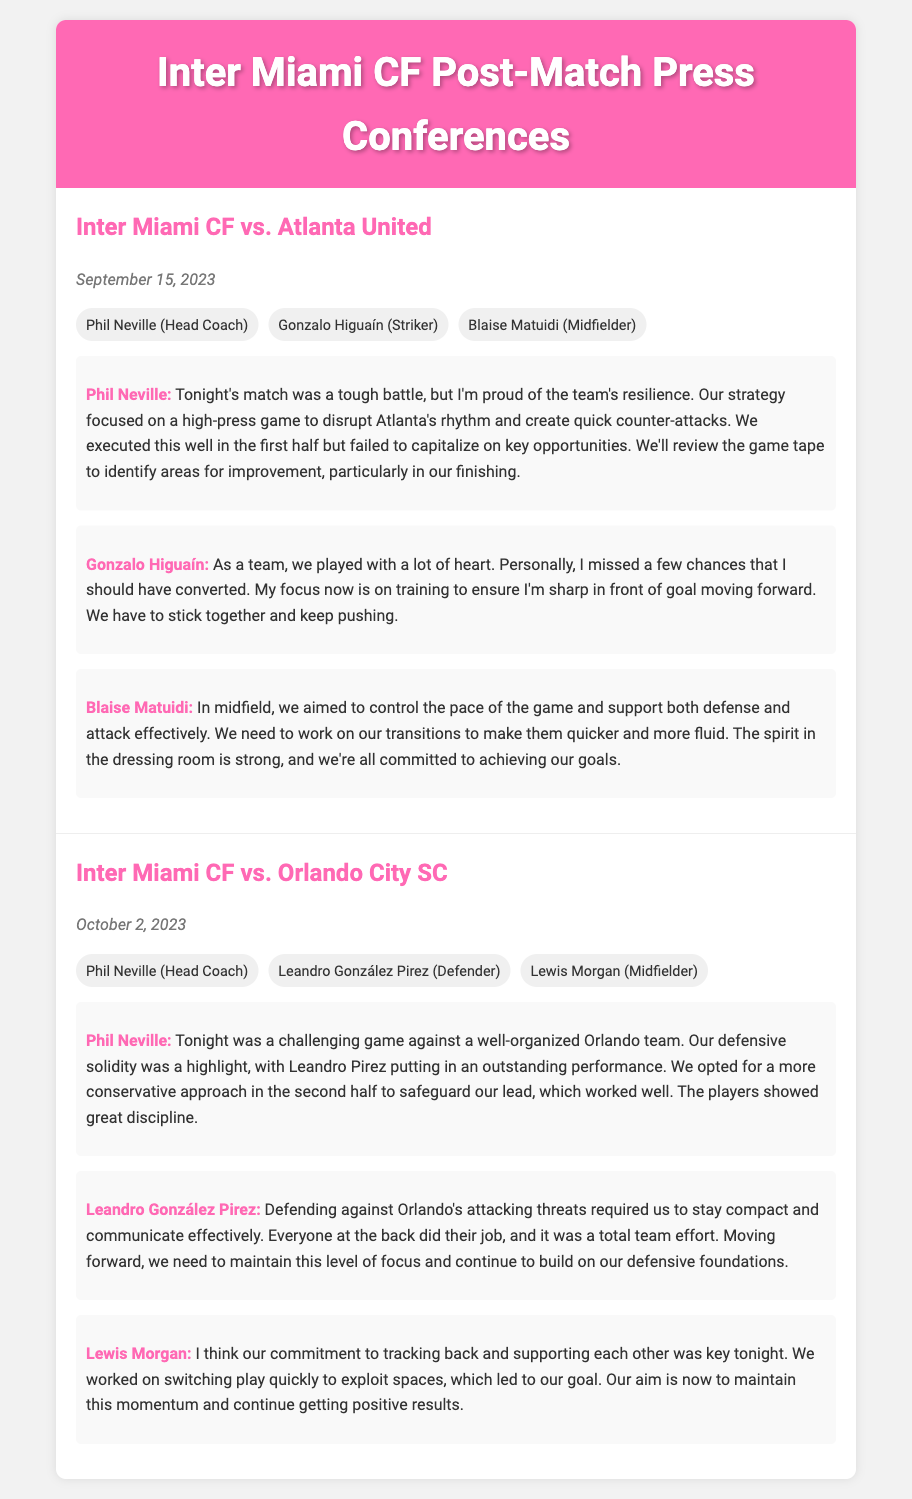What date was the match against Atlanta United? The match against Atlanta United took place on September 15, 2023.
Answer: September 15, 2023 Who made an outstanding performance as noted by Phil Neville against Orlando? Phil Neville highlighted Leandro González Pirez's performance as outstanding in the game against Orlando.
Answer: Leandro González Pirez What was Gonzalo Higuaín's focus following the match against Atlanta United? Gonzalo Higuaín stated that his focus is on training to ensure he's sharp in front of goal moving forward.
Answer: Training How many participants were involved in the press conference for the match against Orlando City SC? There were three participants in the press conference following the match against Orlando City SC.
Answer: Three What strategy did Phil Neville mention for the match against Atlanta United? Phil Neville mentioned that the strategy focused on a high-press game to disrupt Atlanta's rhythm and create quick counter-attacks.
Answer: High-press game Which match resulted in a discussion about defensive solidity? The discussion about defensive solidity occurred after the match against Orlando City SC.
Answer: Orlando City SC What was the main goal that Lewis Morgan emphasized after the match against Orlando? Lewis Morgan emphasized the aim of maintaining momentum and continuing to achieve positive results.
Answer: Maintaining momentum What was a key focus for Blaise Matuidi in the match against Atlanta United? Blaise Matuidi focused on controlling the pace of the game and supporting both defense and attack effectively.
Answer: Controlling the pace 